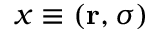Convert formula to latex. <formula><loc_0><loc_0><loc_500><loc_500>x \equiv ( r , \sigma )</formula> 